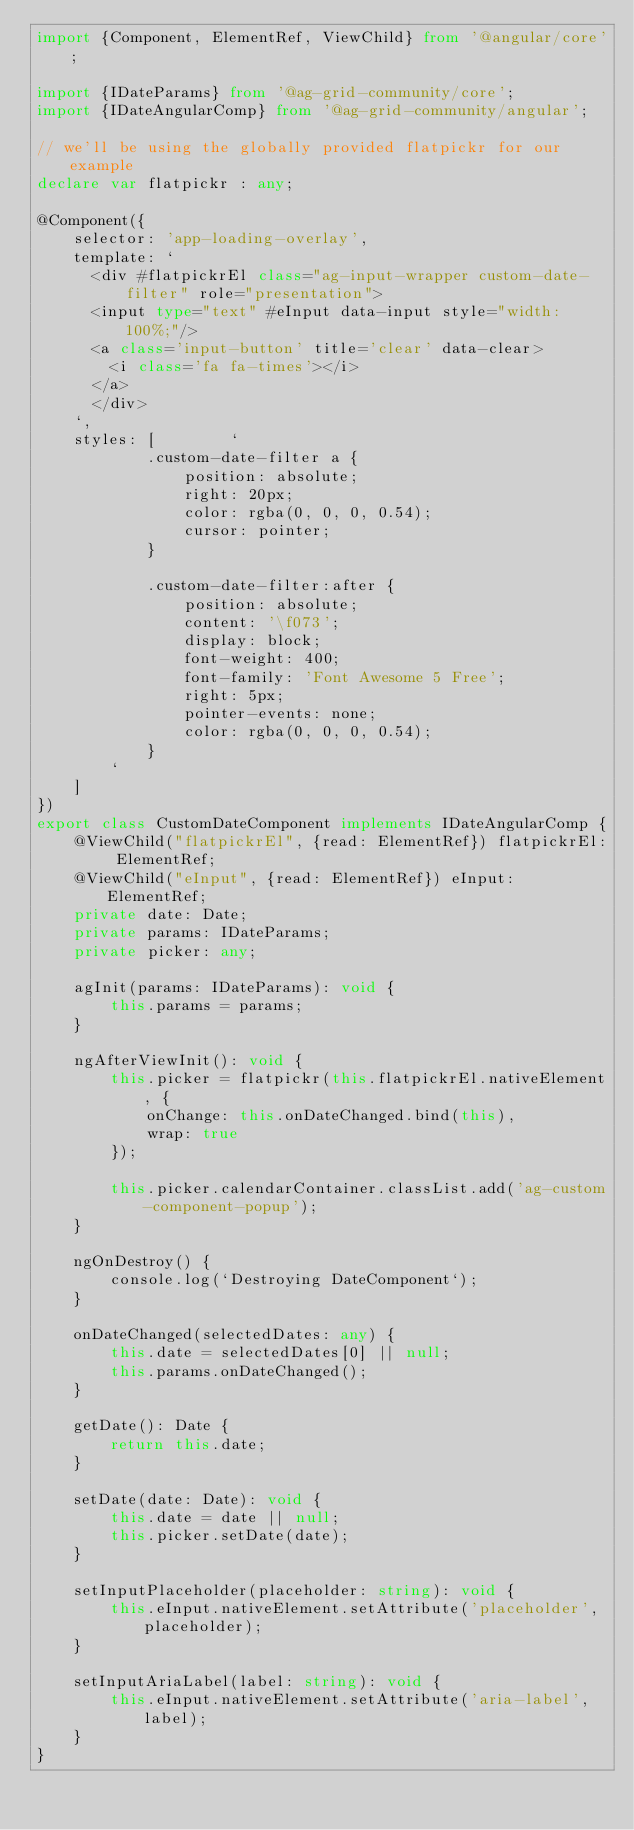Convert code to text. <code><loc_0><loc_0><loc_500><loc_500><_TypeScript_>import {Component, ElementRef, ViewChild} from '@angular/core';

import {IDateParams} from '@ag-grid-community/core';
import {IDateAngularComp} from '@ag-grid-community/angular';

// we'll be using the globally provided flatpickr for our example
declare var flatpickr : any;

@Component({
    selector: 'app-loading-overlay',
    template: `
      <div #flatpickrEl class="ag-input-wrapper custom-date-filter" role="presentation">
      <input type="text" #eInput data-input style="width: 100%;"/>
      <a class='input-button' title='clear' data-clear>
        <i class='fa fa-times'></i>
      </a>
      </div>
    `,
    styles: [        `
            .custom-date-filter a {
                position: absolute;
                right: 20px;
                color: rgba(0, 0, 0, 0.54);
                cursor: pointer;
            }

            .custom-date-filter:after {
                position: absolute;
                content: '\f073';
                display: block;
                font-weight: 400;
                font-family: 'Font Awesome 5 Free';
                right: 5px;
                pointer-events: none;
                color: rgba(0, 0, 0, 0.54);
            }
        `
    ]
})
export class CustomDateComponent implements IDateAngularComp {
    @ViewChild("flatpickrEl", {read: ElementRef}) flatpickrEl: ElementRef;
    @ViewChild("eInput", {read: ElementRef}) eInput: ElementRef;
    private date: Date;
    private params: IDateParams;
    private picker: any;

    agInit(params: IDateParams): void {
        this.params = params;
    }

    ngAfterViewInit(): void {
        this.picker = flatpickr(this.flatpickrEl.nativeElement, {
            onChange: this.onDateChanged.bind(this),
            wrap: true
        });

        this.picker.calendarContainer.classList.add('ag-custom-component-popup');
    }

    ngOnDestroy() {
        console.log(`Destroying DateComponent`);
    }

    onDateChanged(selectedDates: any) {
        this.date = selectedDates[0] || null;
        this.params.onDateChanged();
    }

    getDate(): Date {
        return this.date;
    }

    setDate(date: Date): void {
        this.date = date || null;
        this.picker.setDate(date);
    }

    setInputPlaceholder(placeholder: string): void {
        this.eInput.nativeElement.setAttribute('placeholder', placeholder);
    }

    setInputAriaLabel(label: string): void {
        this.eInput.nativeElement.setAttribute('aria-label', label);
    }
}
</code> 